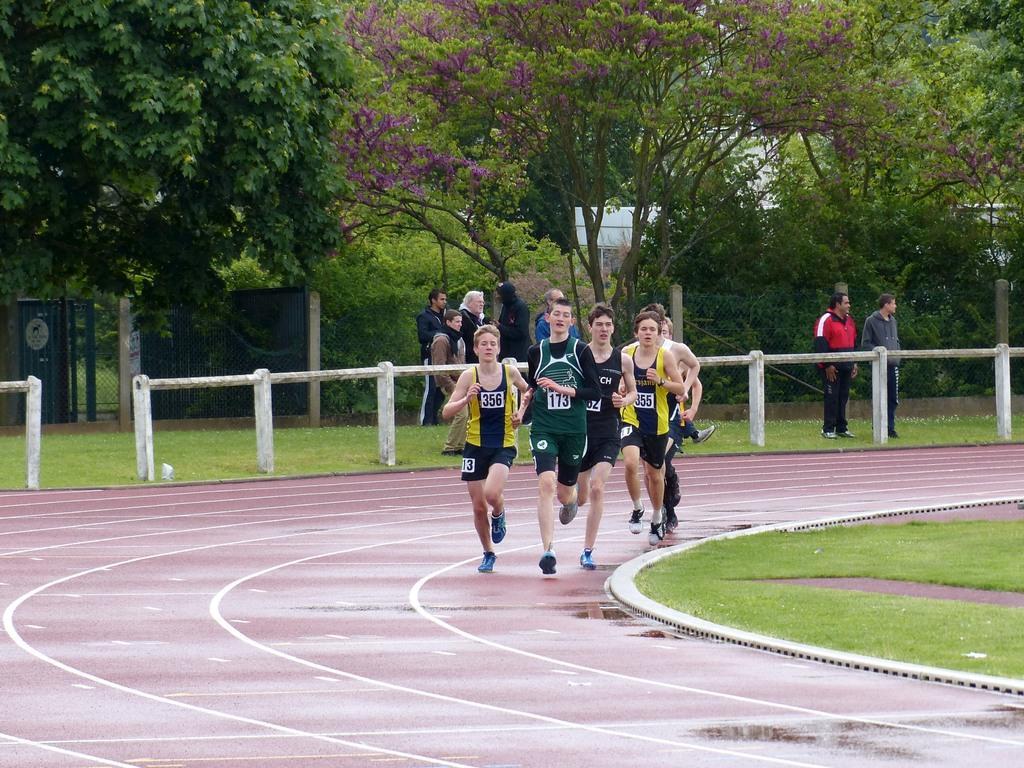Describe this image in one or two sentences. In this image there are people running on the playground, having painted lines. There is a fence on the grassland. Few people are standing on the grassland. Background there are trees. Behind there is a building. Left side there is a fence. Right side there's grass on the land. 